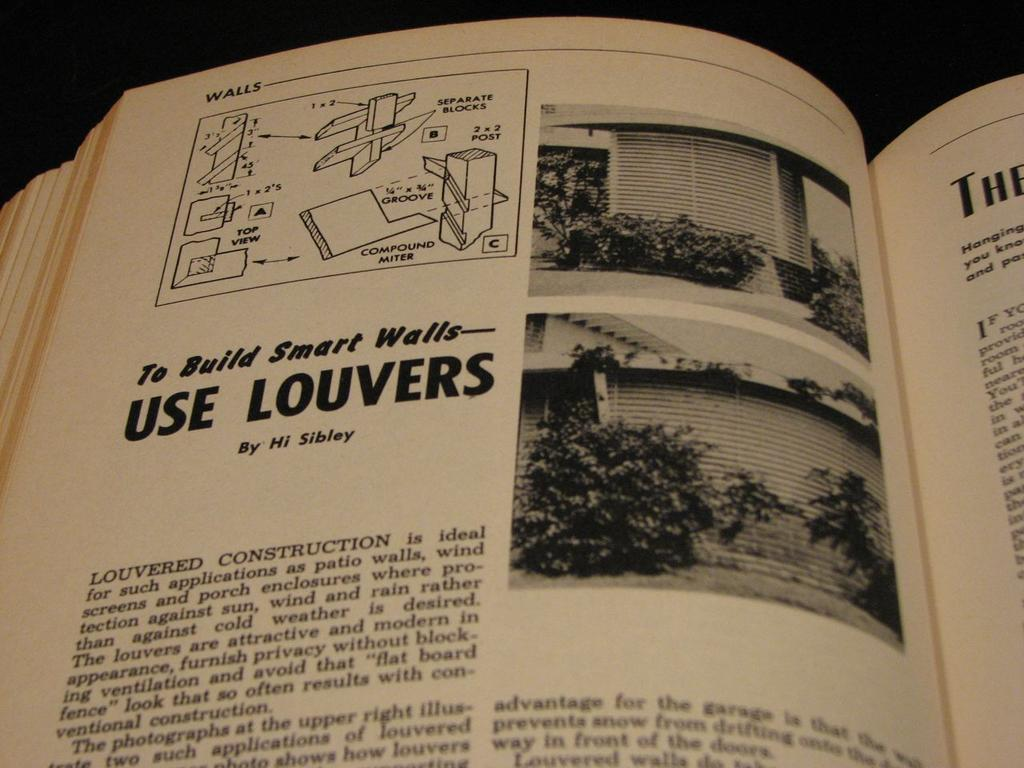Provide a one-sentence caption for the provided image. Book about bilding smart walls and use louvers by Hi Sibley. 